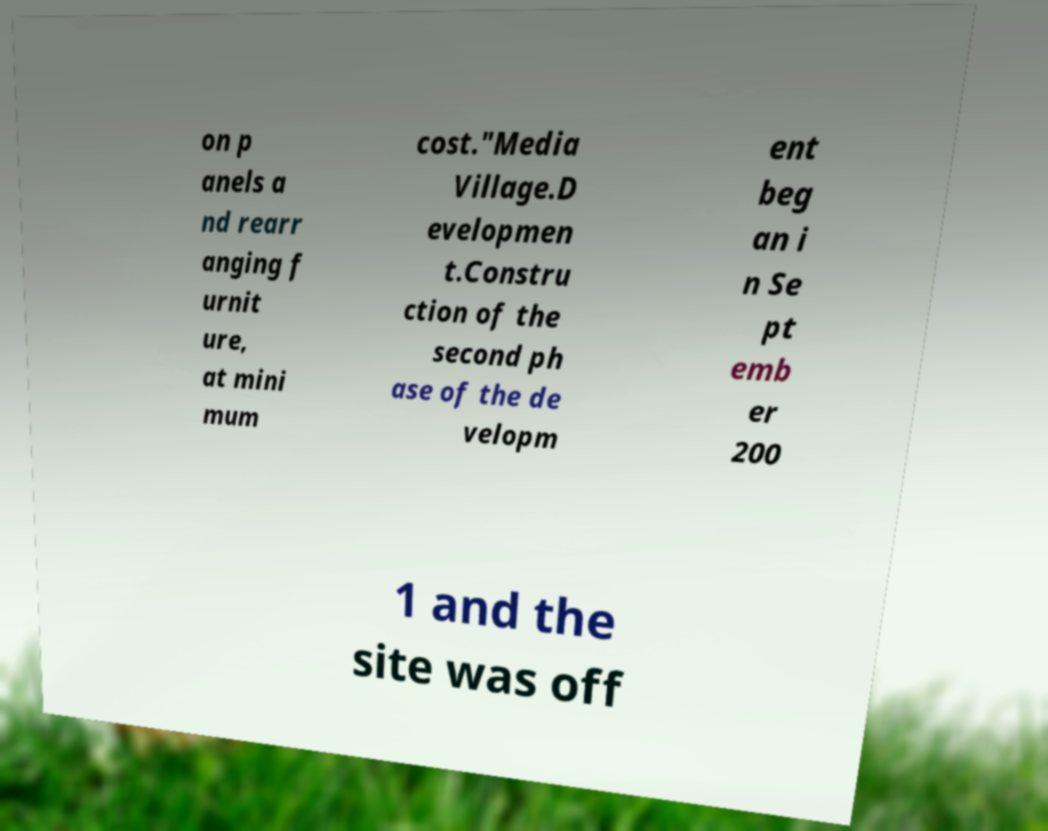I need the written content from this picture converted into text. Can you do that? on p anels a nd rearr anging f urnit ure, at mini mum cost."Media Village.D evelopmen t.Constru ction of the second ph ase of the de velopm ent beg an i n Se pt emb er 200 1 and the site was off 